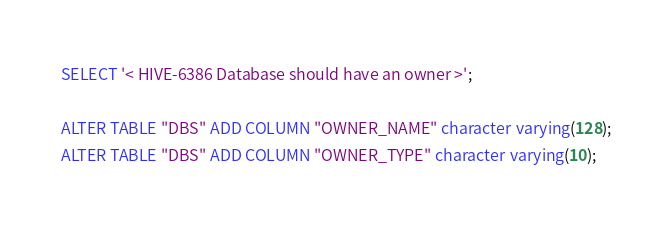Convert code to text. <code><loc_0><loc_0><loc_500><loc_500><_SQL_>SELECT '< HIVE-6386 Database should have an owner >';

ALTER TABLE "DBS" ADD COLUMN "OWNER_NAME" character varying(128);
ALTER TABLE "DBS" ADD COLUMN "OWNER_TYPE" character varying(10);
</code> 